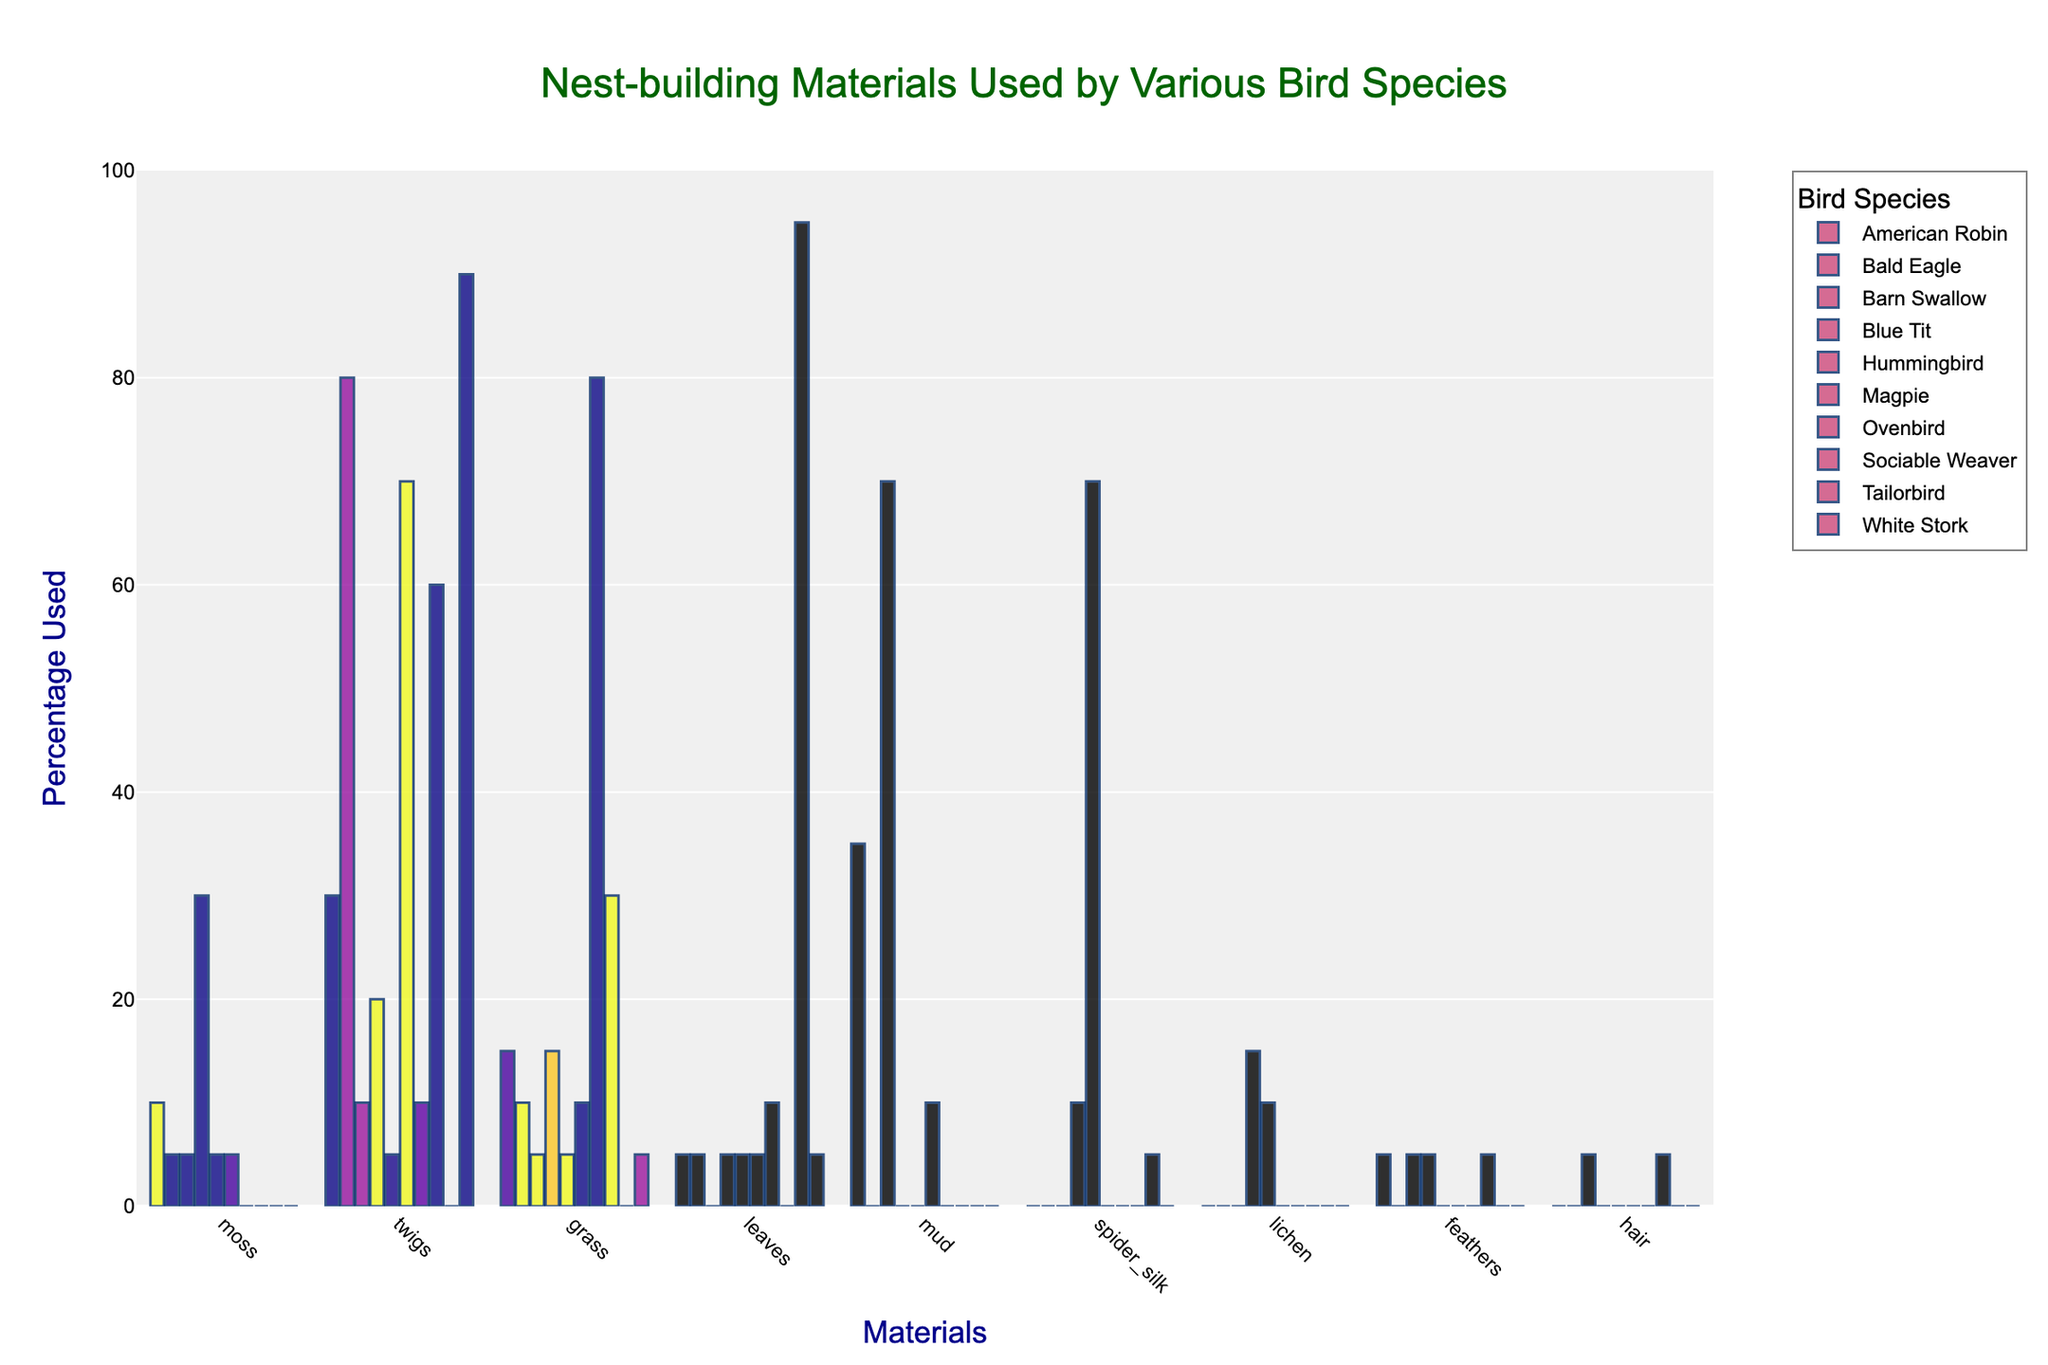Which material is used most frequently overall by all the bird species? To determine the most frequently used material, look for the tallest bar in the figure regardless of the bird species. Each species' bar height represents the percentage use of a material. The material corresponding to the tallest bar is the one used most frequently.
Answer: Twigs Which bird species uses the highest percentage of spider silk in its nests? Identify the bar labeled "spider silk" and note the height of this bar for each bird species. The species with the tallest bar for "spider silk" is the one that uses it the most.
Answer: Hummingbird Among the materials moss, grass, and twigs, which one does the American Robin use the most, and by what percentage? Examine the bars for American Robin for moss, grass, and twigs. Compare their heights to identify which is tallest and note the corresponding percentage.
Answer: Twigs, 30% How does the use of leaves by the Blue Tit compare to its use by the Tailorbird? Locate the bar for leaves for both Blue Tit and Tailorbird. Compare the heights of these bars to determine which species uses more leaves.
Answer: The Tailorbird uses more leaves Which material has the least average use across all bird species? Calculate the average usage of each material by summing the percentages for each material across all species and then dividing by the number of species (9). The material with the smallest average is the least used.
Answer: Hair How many bird species use mud in their nest-building? Count the number of species with a non-zero bar for mud. This is done by identifying the bars for mud and checking their height for each species.
Answer: 3 What is the difference in twig usage between the Bald Eagle and Blue Tit? Find the percentage of twigs used by the Bald Eagle and Blue Tit by looking at the height of the bars labeled for twigs. Subtract the smaller percentage from the larger one.
Answer: 60% Does any bird species not use grass in its nests? If yes, name the species. Check all bird species' bars for the material grass. Any species with a height of zero for grass indicates non-usage.
Answer: Tailorbird What percentage of nest-building materials used by the Barn Swallow consists of mud and twigs combined? Locate the bars for mud and twigs for the Barn Swallow. Add their percentages to get the combined total.
Answer: 80% 